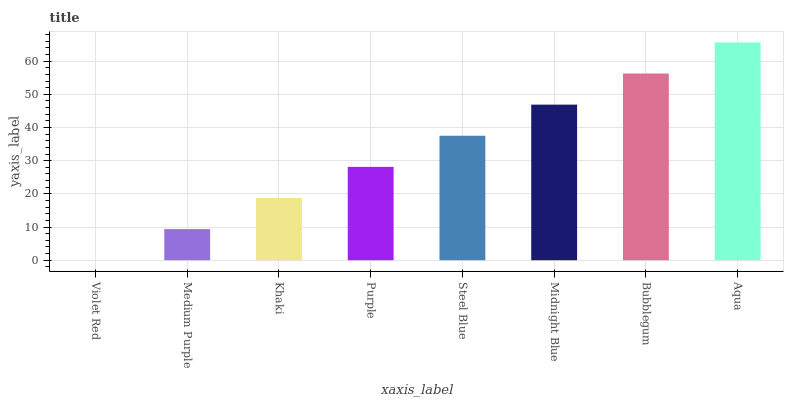Is Medium Purple the minimum?
Answer yes or no. No. Is Medium Purple the maximum?
Answer yes or no. No. Is Medium Purple greater than Violet Red?
Answer yes or no. Yes. Is Violet Red less than Medium Purple?
Answer yes or no. Yes. Is Violet Red greater than Medium Purple?
Answer yes or no. No. Is Medium Purple less than Violet Red?
Answer yes or no. No. Is Steel Blue the high median?
Answer yes or no. Yes. Is Purple the low median?
Answer yes or no. Yes. Is Khaki the high median?
Answer yes or no. No. Is Midnight Blue the low median?
Answer yes or no. No. 